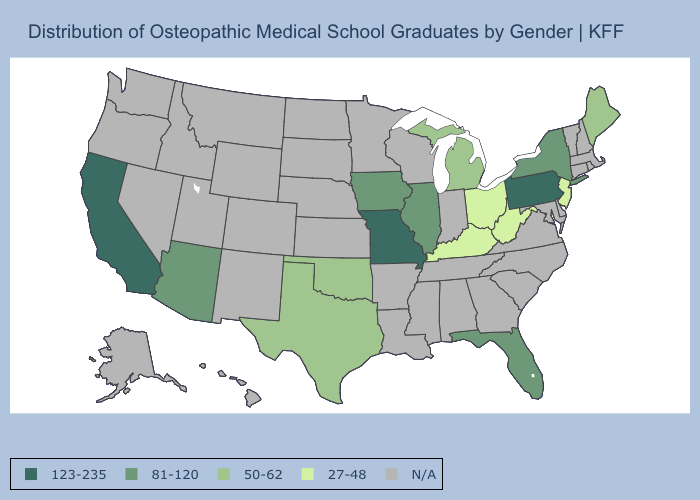What is the highest value in the USA?
Quick response, please. 123-235. Which states have the lowest value in the USA?
Short answer required. Kentucky, New Jersey, Ohio, West Virginia. What is the highest value in the USA?
Quick response, please. 123-235. What is the value of Hawaii?
Quick response, please. N/A. Which states have the lowest value in the USA?
Short answer required. Kentucky, New Jersey, Ohio, West Virginia. Does Missouri have the highest value in the USA?
Keep it brief. Yes. Name the states that have a value in the range 50-62?
Be succinct. Maine, Michigan, Oklahoma, Texas. Does Pennsylvania have the highest value in the USA?
Give a very brief answer. Yes. Name the states that have a value in the range N/A?
Keep it brief. Alabama, Alaska, Arkansas, Colorado, Connecticut, Delaware, Georgia, Hawaii, Idaho, Indiana, Kansas, Louisiana, Maryland, Massachusetts, Minnesota, Mississippi, Montana, Nebraska, Nevada, New Hampshire, New Mexico, North Carolina, North Dakota, Oregon, Rhode Island, South Carolina, South Dakota, Tennessee, Utah, Vermont, Virginia, Washington, Wisconsin, Wyoming. What is the value of Delaware?
Short answer required. N/A. What is the highest value in the USA?
Keep it brief. 123-235. What is the highest value in the USA?
Write a very short answer. 123-235. Does the map have missing data?
Be succinct. Yes. Name the states that have a value in the range 123-235?
Keep it brief. California, Missouri, Pennsylvania. 